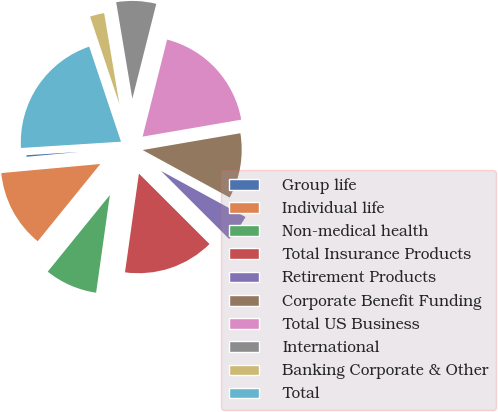Convert chart to OTSL. <chart><loc_0><loc_0><loc_500><loc_500><pie_chart><fcel>Group life<fcel>Individual life<fcel>Non-medical health<fcel>Total Insurance Products<fcel>Retirement Products<fcel>Corporate Benefit Funding<fcel>Total US Business<fcel>International<fcel>Banking Corporate & Other<fcel>Total<nl><fcel>0.46%<fcel>12.7%<fcel>8.62%<fcel>14.74%<fcel>4.54%<fcel>10.66%<fcel>18.36%<fcel>6.58%<fcel>2.5%<fcel>20.86%<nl></chart> 